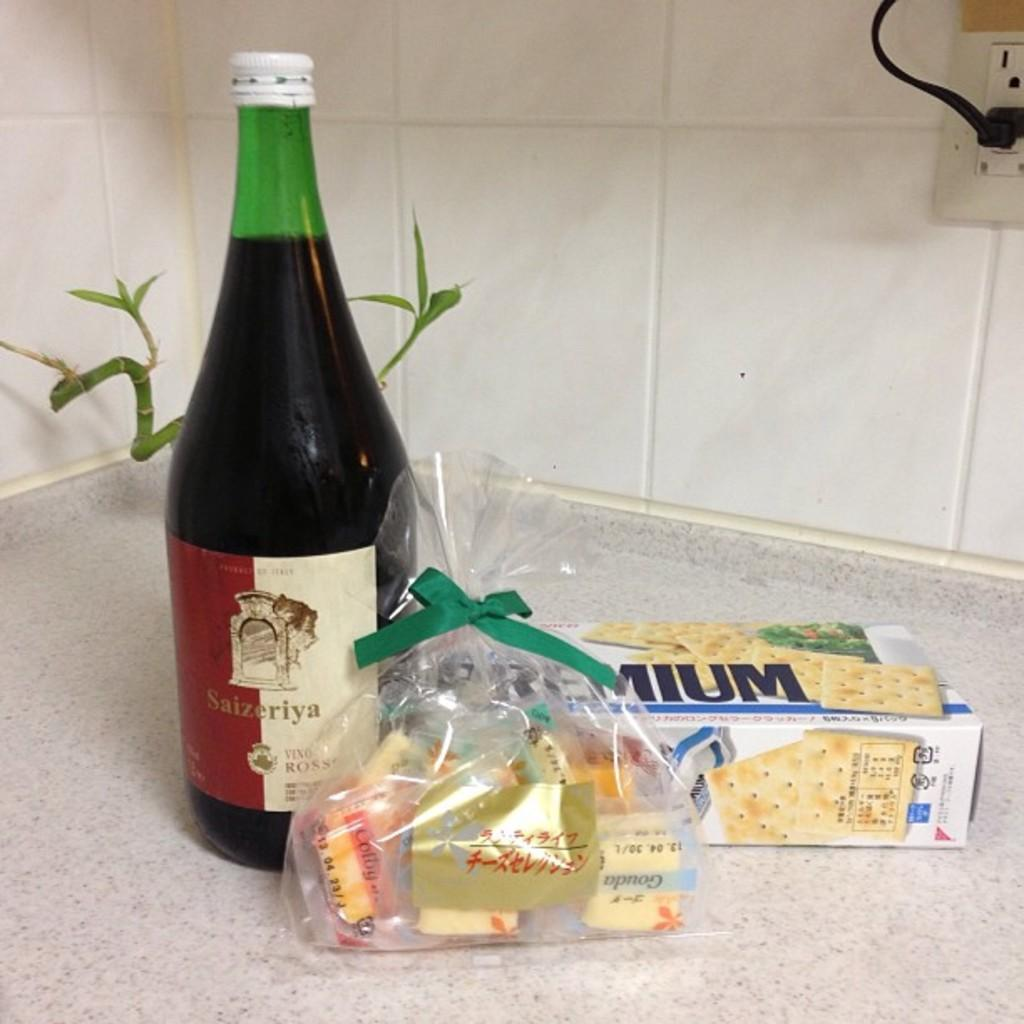<image>
Present a compact description of the photo's key features. Box of crackers and a bottle Saizeriya red wine. 